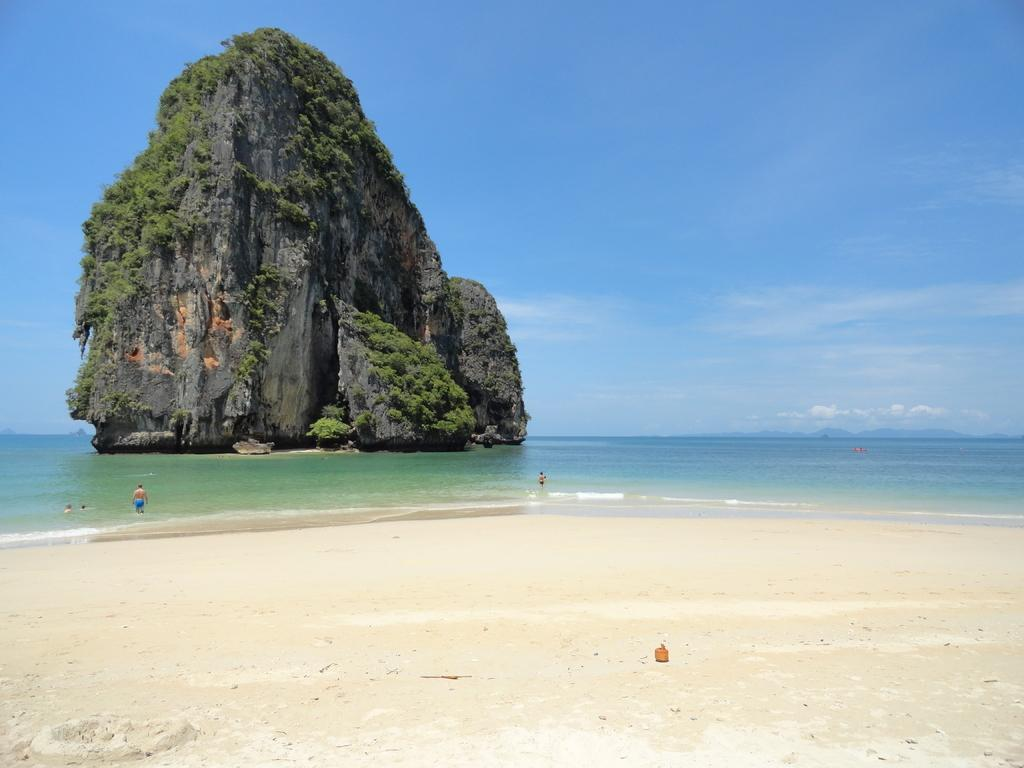What is located on the left side of the image? There is a hill on the left side of the image. What is the man in the image doing? A man is walking in the water in the image. What type of terrain is present in the image? There is sand in the image. What is visible at the top of the image? The sky is visible at the top of the image. What is the weather like in the image? The sky appears to be sunny, suggesting a clear and warm day. What type of pet can be seen playing with a duck in the image? There is no pet or duck present in the image; it features a hill, a man walking in the water, sand, and a sunny sky. 